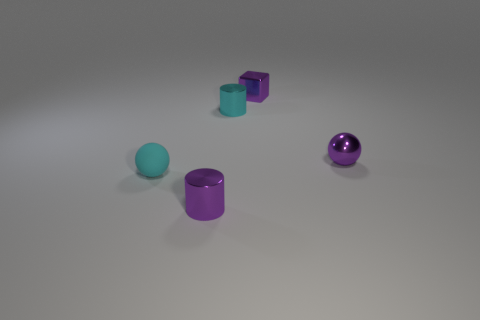Are there more purple balls in front of the tiny cyan cylinder than big purple balls?
Give a very brief answer. Yes. There is a cyan cylinder that is the same size as the block; what is its material?
Give a very brief answer. Metal. Are there any matte spheres of the same size as the cyan shiny cylinder?
Your answer should be compact. Yes. What size is the cyan thing that is behind the small purple sphere?
Provide a short and direct response. Small. What size is the purple block?
Keep it short and to the point. Small. How many cylinders are tiny cyan rubber things or tiny brown matte objects?
Give a very brief answer. 0. The cyan cylinder that is the same material as the tiny cube is what size?
Keep it short and to the point. Small. How many things have the same color as the small shiny block?
Ensure brevity in your answer.  2. Are there any small cylinders in front of the small metallic sphere?
Make the answer very short. Yes. Does the cyan metallic object have the same shape as the purple object that is in front of the tiny purple sphere?
Make the answer very short. Yes. 